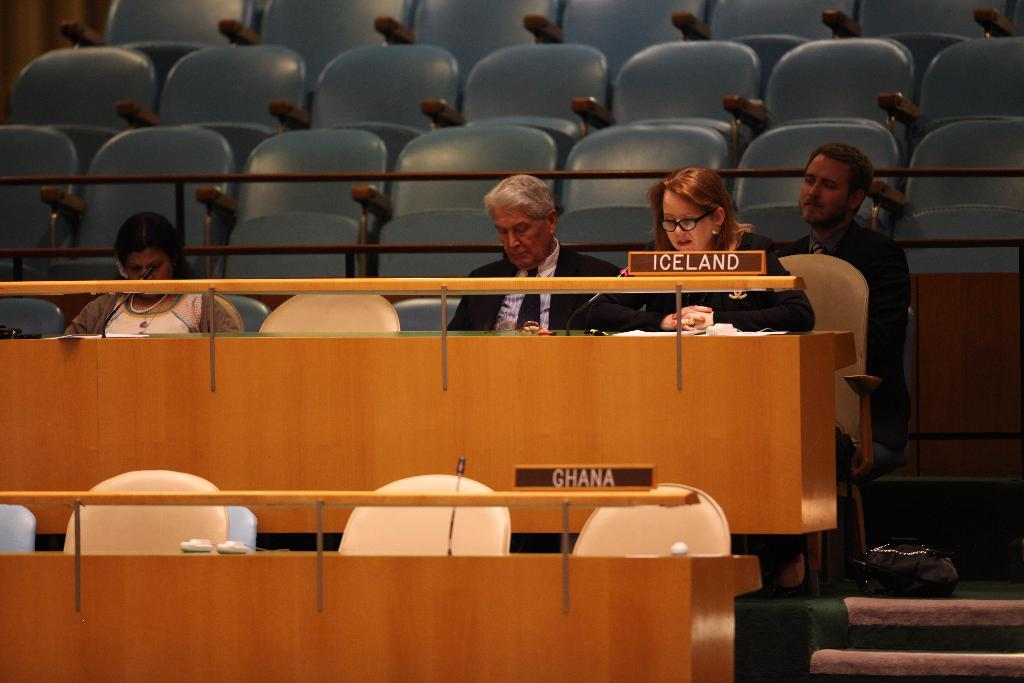Provide a one-sentence caption for the provided image. Several politicians sit behind an Iceland name plate during a conference. 